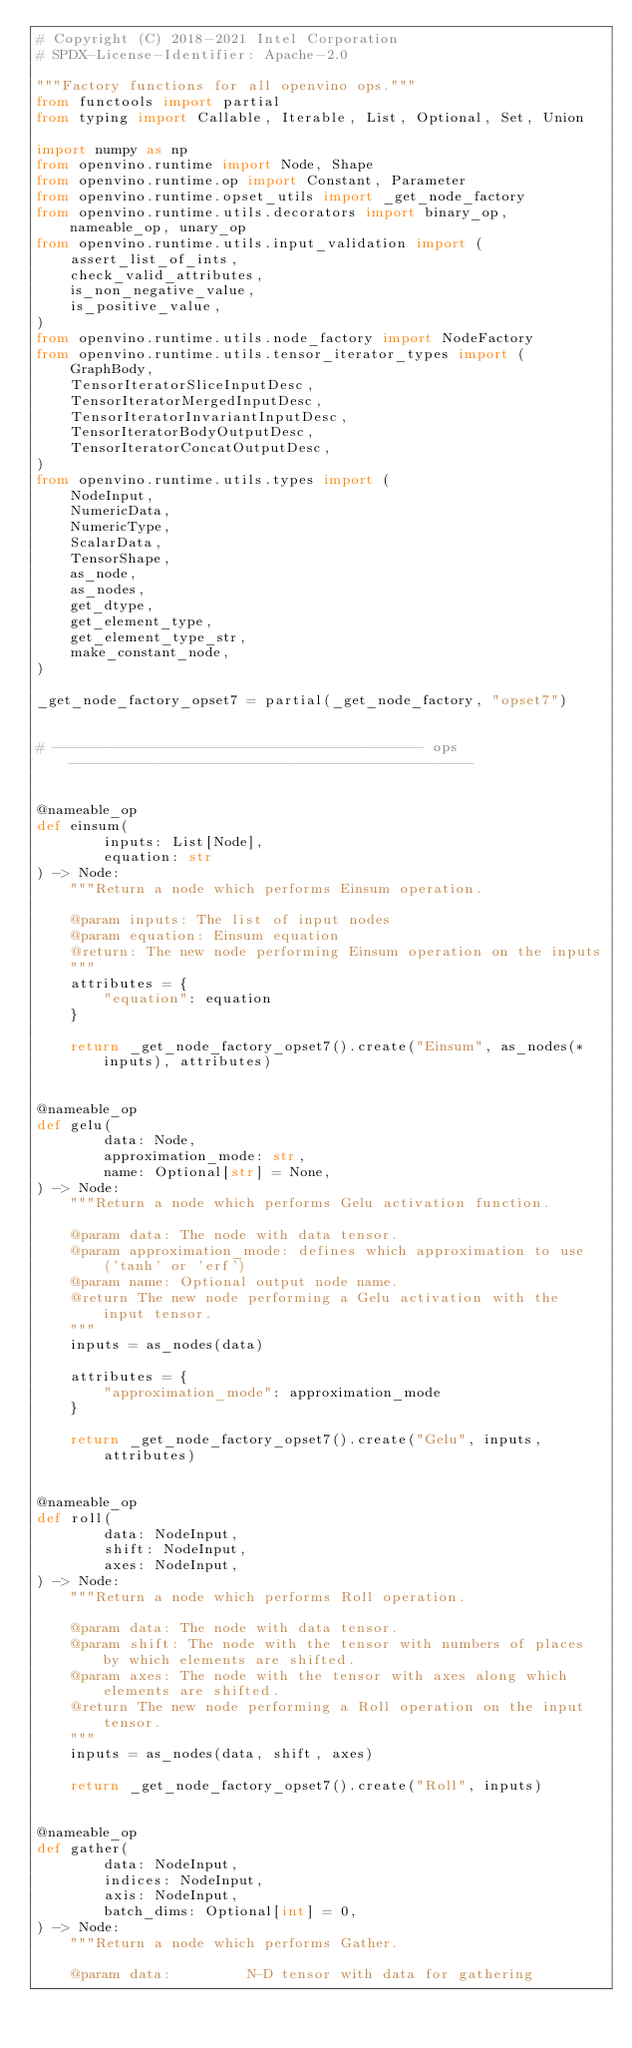<code> <loc_0><loc_0><loc_500><loc_500><_Python_># Copyright (C) 2018-2021 Intel Corporation
# SPDX-License-Identifier: Apache-2.0

"""Factory functions for all openvino ops."""
from functools import partial
from typing import Callable, Iterable, List, Optional, Set, Union

import numpy as np
from openvino.runtime import Node, Shape
from openvino.runtime.op import Constant, Parameter
from openvino.runtime.opset_utils import _get_node_factory
from openvino.runtime.utils.decorators import binary_op, nameable_op, unary_op
from openvino.runtime.utils.input_validation import (
    assert_list_of_ints,
    check_valid_attributes,
    is_non_negative_value,
    is_positive_value,
)
from openvino.runtime.utils.node_factory import NodeFactory
from openvino.runtime.utils.tensor_iterator_types import (
    GraphBody,
    TensorIteratorSliceInputDesc,
    TensorIteratorMergedInputDesc,
    TensorIteratorInvariantInputDesc,
    TensorIteratorBodyOutputDesc,
    TensorIteratorConcatOutputDesc,
)
from openvino.runtime.utils.types import (
    NodeInput,
    NumericData,
    NumericType,
    ScalarData,
    TensorShape,
    as_node,
    as_nodes,
    get_dtype,
    get_element_type,
    get_element_type_str,
    make_constant_node,
)

_get_node_factory_opset7 = partial(_get_node_factory, "opset7")


# -------------------------------------------- ops ------------------------------------------------


@nameable_op
def einsum(
        inputs: List[Node],
        equation: str
) -> Node:
    """Return a node which performs Einsum operation.

    @param inputs: The list of input nodes
    @param equation: Einsum equation
    @return: The new node performing Einsum operation on the inputs
    """
    attributes = {
        "equation": equation
    }

    return _get_node_factory_opset7().create("Einsum", as_nodes(*inputs), attributes)


@nameable_op
def gelu(
        data: Node,
        approximation_mode: str,
        name: Optional[str] = None,
) -> Node:
    """Return a node which performs Gelu activation function.

    @param data: The node with data tensor.
    @param approximation_mode: defines which approximation to use ('tanh' or 'erf')
    @param name: Optional output node name.
    @return The new node performing a Gelu activation with the input tensor.
    """
    inputs = as_nodes(data)

    attributes = {
        "approximation_mode": approximation_mode
    }

    return _get_node_factory_opset7().create("Gelu", inputs, attributes)


@nameable_op
def roll(
        data: NodeInput,
        shift: NodeInput,
        axes: NodeInput,
) -> Node:
    """Return a node which performs Roll operation.

    @param data: The node with data tensor.
    @param shift: The node with the tensor with numbers of places by which elements are shifted.
    @param axes: The node with the tensor with axes along which elements are shifted.
    @return The new node performing a Roll operation on the input tensor.
    """
    inputs = as_nodes(data, shift, axes)

    return _get_node_factory_opset7().create("Roll", inputs)


@nameable_op
def gather(
        data: NodeInput,
        indices: NodeInput,
        axis: NodeInput,
        batch_dims: Optional[int] = 0,
) -> Node:
    """Return a node which performs Gather.

    @param data:         N-D tensor with data for gathering</code> 